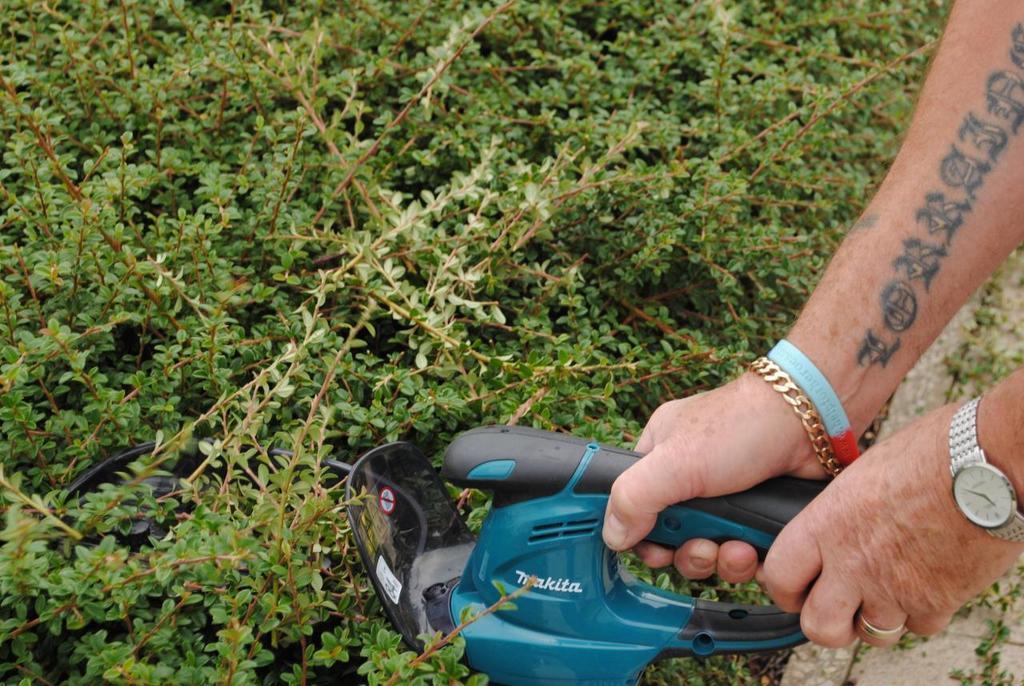Can you describe this image briefly? There is one person holding an object as we can see on the right side of this image. We can see plants in the background. 